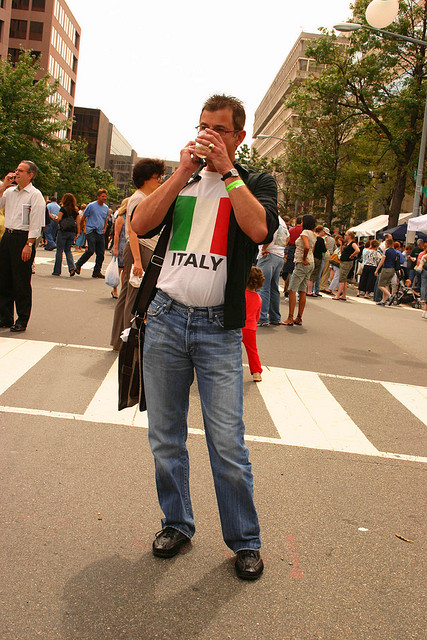Identify the text displayed in this image. ITALY 